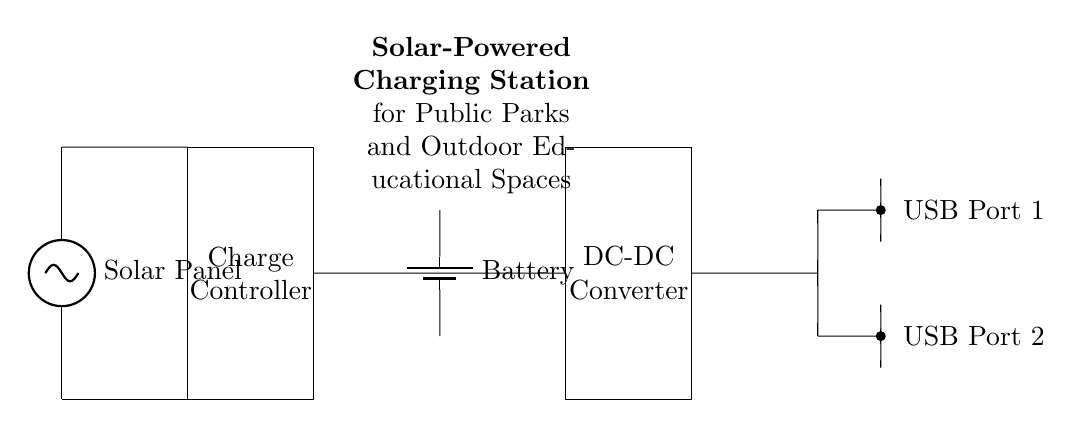What is the primary energy source in this circuit? The primary energy source is the solar panel, which captures sunlight and converts it into electrical energy.
Answer: solar panel How many USB ports are available for charging? There are two USB ports available for charging devices in this circuit, as clearly labeled near the output connections.
Answer: two What component regulates the battery charging? The charge controller is responsible for regulating the battery's charging process, ensuring it is charged safely and efficiently from the solar panel.
Answer: charge controller What is the purpose of the DC-DC converter? The DC-DC converter adjusts the voltage level from the battery to meet the output requirements for the USB ports, allowing for efficient charging of devices.
Answer: voltage adjustment What is the overall function of this circuit? The circuit serves as a solar-powered charging station, designed to provide electrical energy for personal devices in public parks and outdoor educational spaces.
Answer: charging station 